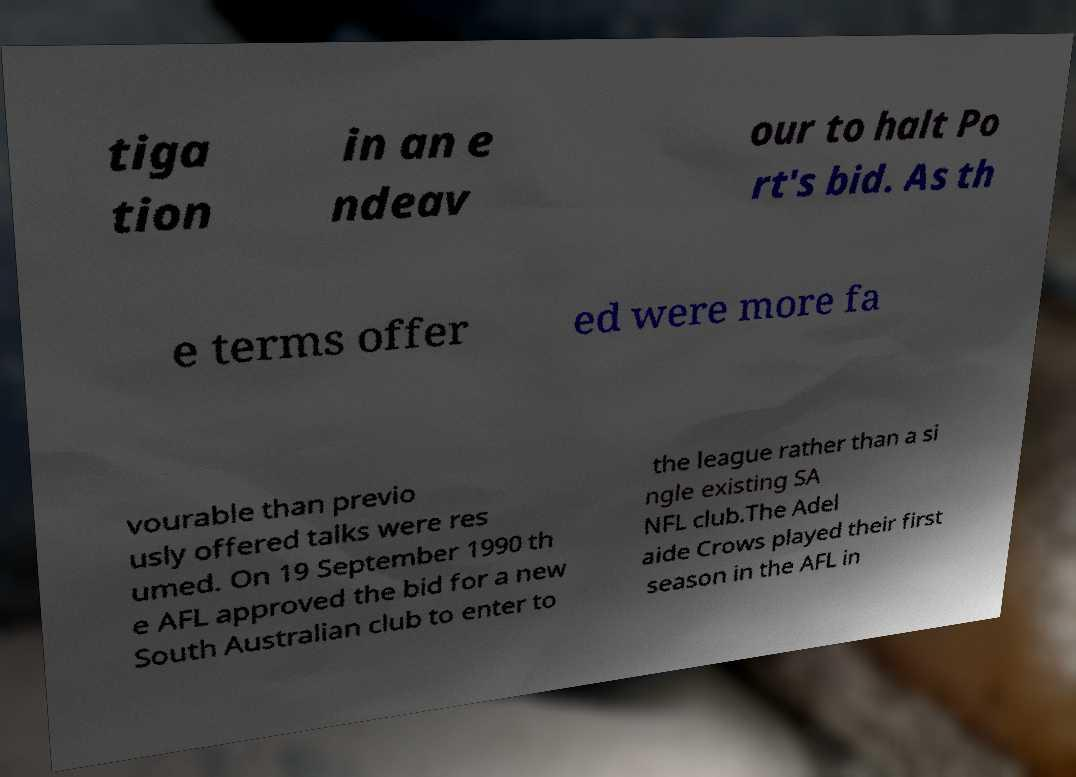What messages or text are displayed in this image? I need them in a readable, typed format. tiga tion in an e ndeav our to halt Po rt's bid. As th e terms offer ed were more fa vourable than previo usly offered talks were res umed. On 19 September 1990 th e AFL approved the bid for a new South Australian club to enter to the league rather than a si ngle existing SA NFL club.The Adel aide Crows played their first season in the AFL in 